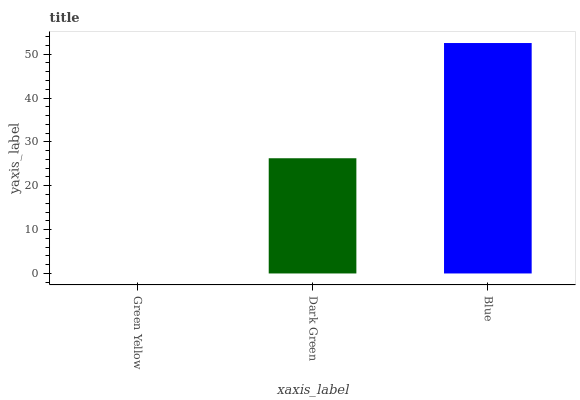Is Green Yellow the minimum?
Answer yes or no. Yes. Is Blue the maximum?
Answer yes or no. Yes. Is Dark Green the minimum?
Answer yes or no. No. Is Dark Green the maximum?
Answer yes or no. No. Is Dark Green greater than Green Yellow?
Answer yes or no. Yes. Is Green Yellow less than Dark Green?
Answer yes or no. Yes. Is Green Yellow greater than Dark Green?
Answer yes or no. No. Is Dark Green less than Green Yellow?
Answer yes or no. No. Is Dark Green the high median?
Answer yes or no. Yes. Is Dark Green the low median?
Answer yes or no. Yes. Is Blue the high median?
Answer yes or no. No. Is Blue the low median?
Answer yes or no. No. 